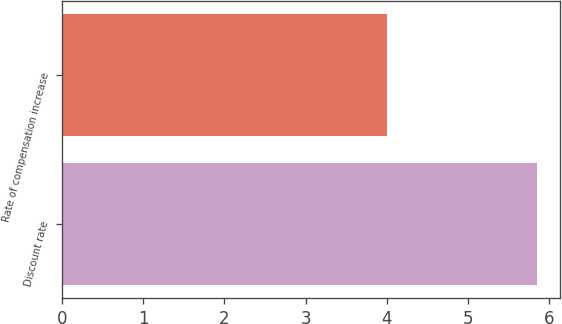<chart> <loc_0><loc_0><loc_500><loc_500><bar_chart><fcel>Discount rate<fcel>Rate of compensation increase<nl><fcel>5.85<fcel>4<nl></chart> 